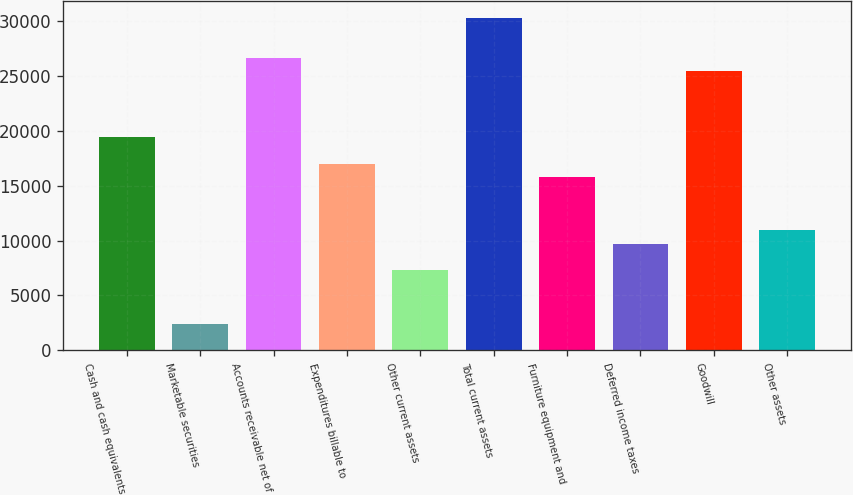<chart> <loc_0><loc_0><loc_500><loc_500><bar_chart><fcel>Cash and cash equivalents<fcel>Marketable securities<fcel>Accounts receivable net of<fcel>Expenditures billable to<fcel>Other current assets<fcel>Total current assets<fcel>Furniture equipment and<fcel>Deferred income taxes<fcel>Goodwill<fcel>Other assets<nl><fcel>19391.9<fcel>2436.24<fcel>26658.6<fcel>16969.7<fcel>7280.72<fcel>30292<fcel>15758.6<fcel>9702.96<fcel>25447.5<fcel>10914.1<nl></chart> 